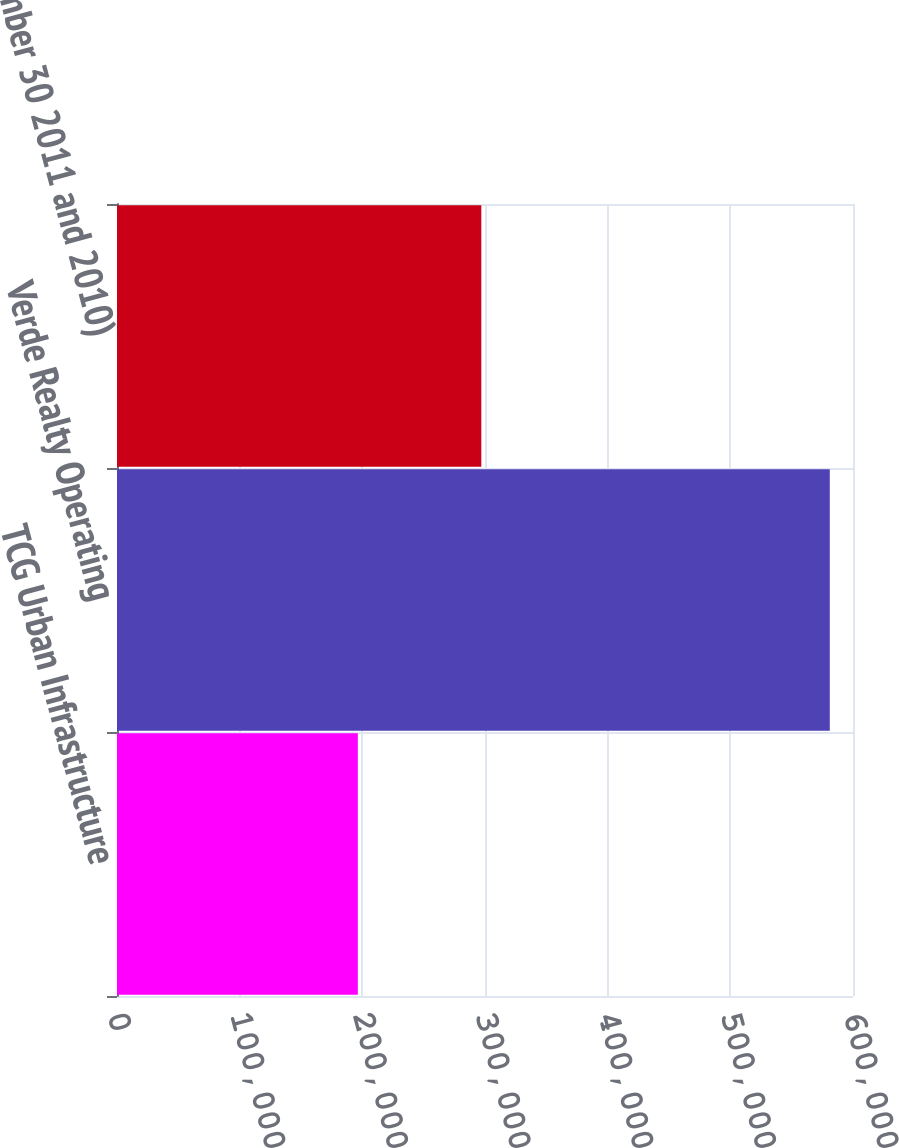Convert chart to OTSL. <chart><loc_0><loc_0><loc_500><loc_500><bar_chart><fcel>TCG Urban Infrastructure<fcel>Verde Realty Operating<fcel>September 30 2011 and 2010)<nl><fcel>196319<fcel>581086<fcel>296991<nl></chart> 